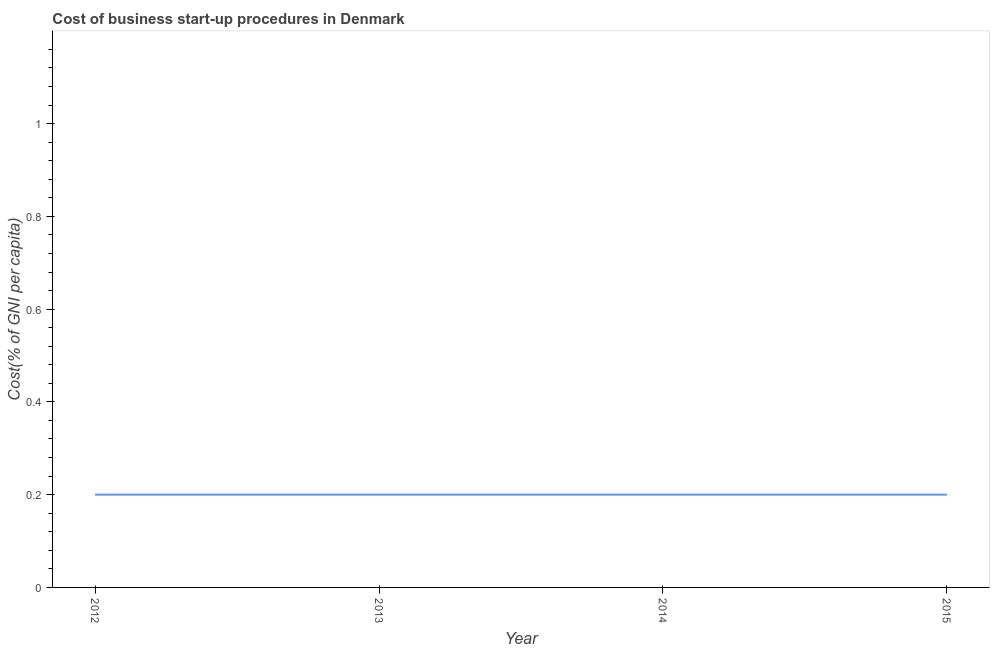What is the cost of business startup procedures in 2015?
Provide a succinct answer. 0.2. Across all years, what is the maximum cost of business startup procedures?
Provide a succinct answer. 0.2. In which year was the cost of business startup procedures minimum?
Your answer should be compact. 2012. In how many years, is the cost of business startup procedures greater than 0.44 %?
Offer a terse response. 0. Do a majority of the years between 2013 and 2014 (inclusive) have cost of business startup procedures greater than 0.92 %?
Your answer should be very brief. No. Is the cost of business startup procedures in 2013 less than that in 2014?
Offer a terse response. No. What is the difference between the highest and the second highest cost of business startup procedures?
Provide a succinct answer. 0. What is the difference between the highest and the lowest cost of business startup procedures?
Keep it short and to the point. 0. Does the cost of business startup procedures monotonically increase over the years?
Your response must be concise. No. How many years are there in the graph?
Offer a very short reply. 4. What is the difference between two consecutive major ticks on the Y-axis?
Make the answer very short. 0.2. Does the graph contain any zero values?
Your answer should be compact. No. What is the title of the graph?
Provide a short and direct response. Cost of business start-up procedures in Denmark. What is the label or title of the Y-axis?
Ensure brevity in your answer.  Cost(% of GNI per capita). What is the Cost(% of GNI per capita) of 2012?
Keep it short and to the point. 0.2. What is the difference between the Cost(% of GNI per capita) in 2012 and 2013?
Provide a short and direct response. 0. What is the difference between the Cost(% of GNI per capita) in 2012 and 2014?
Provide a succinct answer. 0. What is the difference between the Cost(% of GNI per capita) in 2014 and 2015?
Ensure brevity in your answer.  0. What is the ratio of the Cost(% of GNI per capita) in 2013 to that in 2015?
Your answer should be very brief. 1. What is the ratio of the Cost(% of GNI per capita) in 2014 to that in 2015?
Provide a short and direct response. 1. 